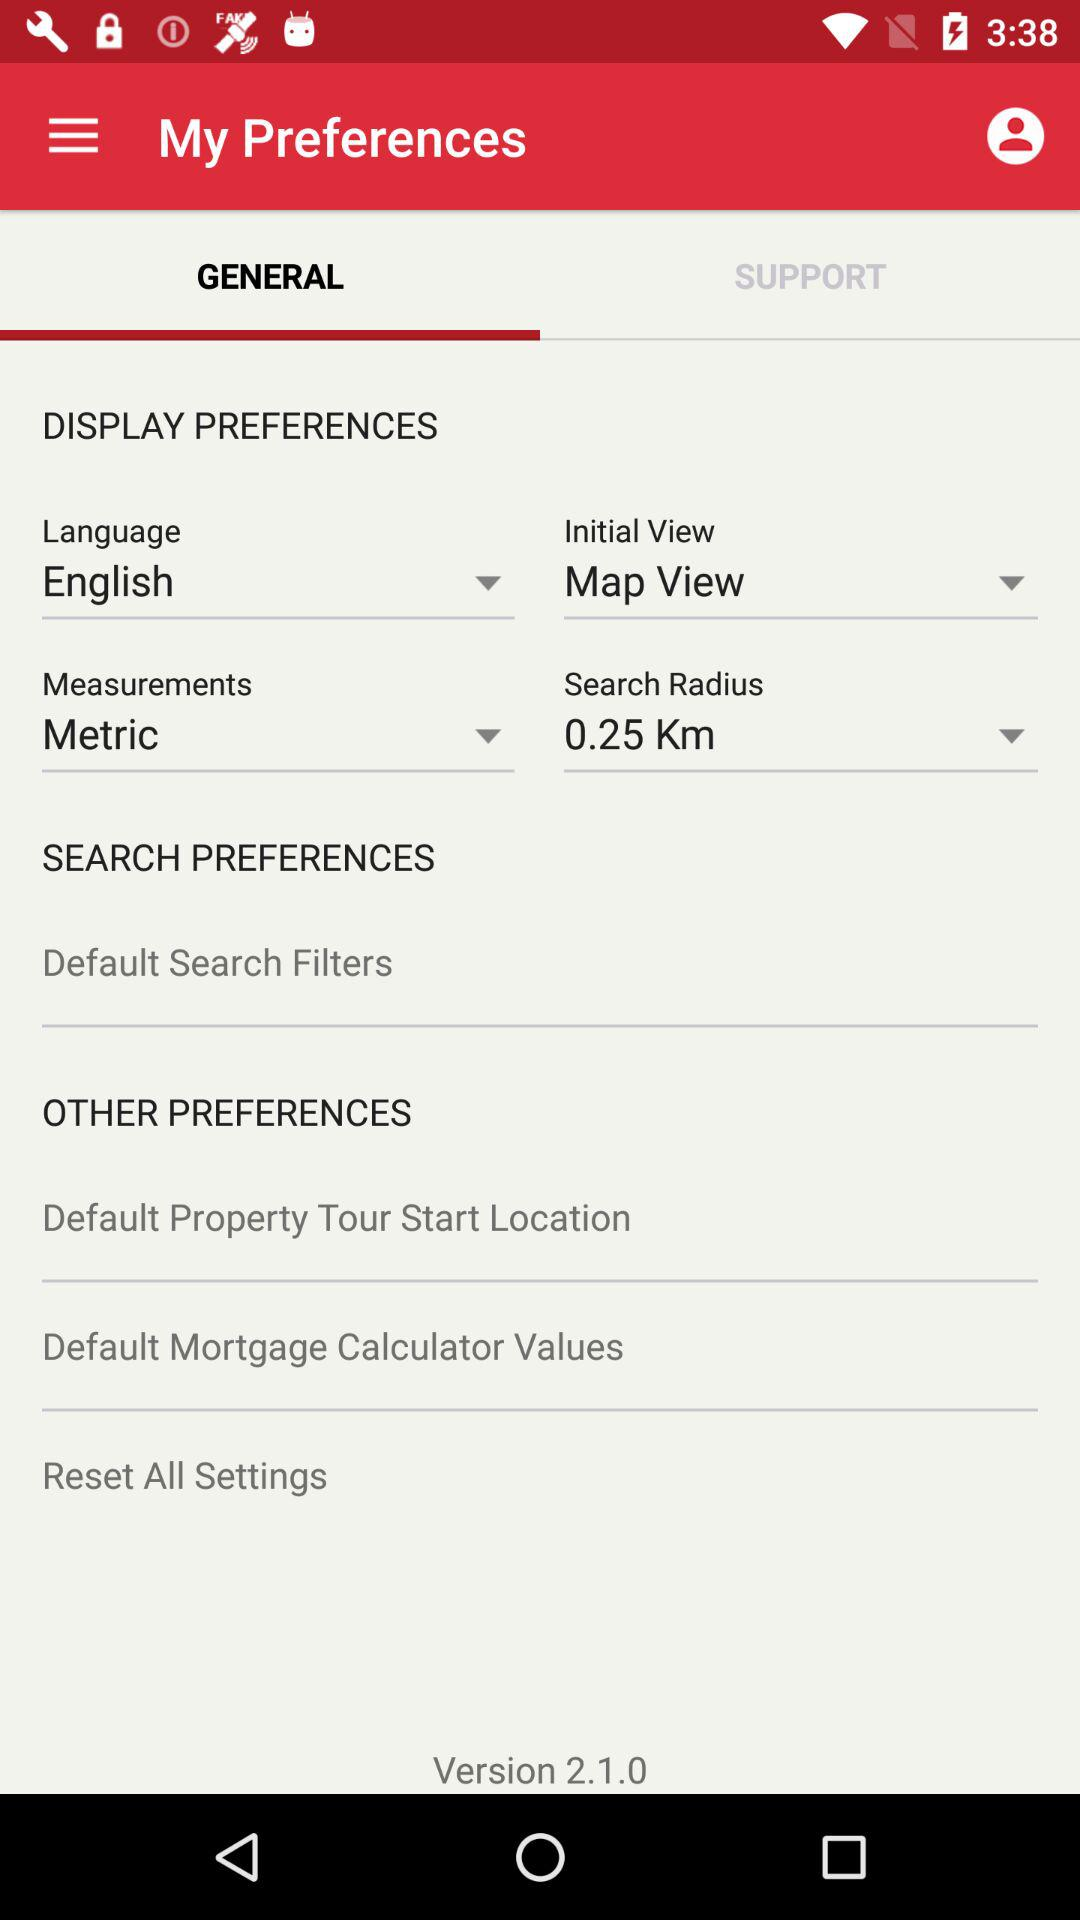What is the version of the app? The version of the app is 2.1.0. 